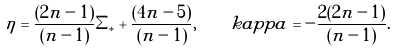Convert formula to latex. <formula><loc_0><loc_0><loc_500><loc_500>\eta = \frac { ( 2 n - 1 ) } { ( n - 1 ) } \Sigma _ { * } + \frac { ( 4 n - 5 ) } { ( n - 1 ) } , \quad k a p p a = - \frac { 2 ( 2 n - 1 ) } { ( n - 1 ) } .</formula> 